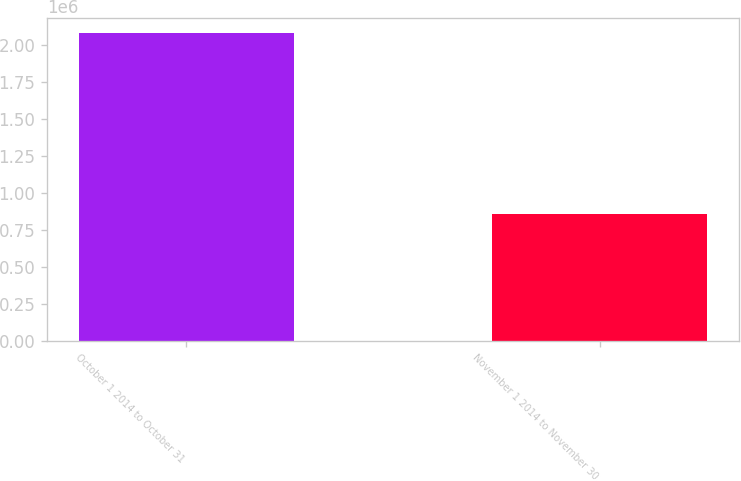Convert chart. <chart><loc_0><loc_0><loc_500><loc_500><bar_chart><fcel>October 1 2014 to October 31<fcel>November 1 2014 to November 30<nl><fcel>2.08056e+06<fcel>857045<nl></chart> 